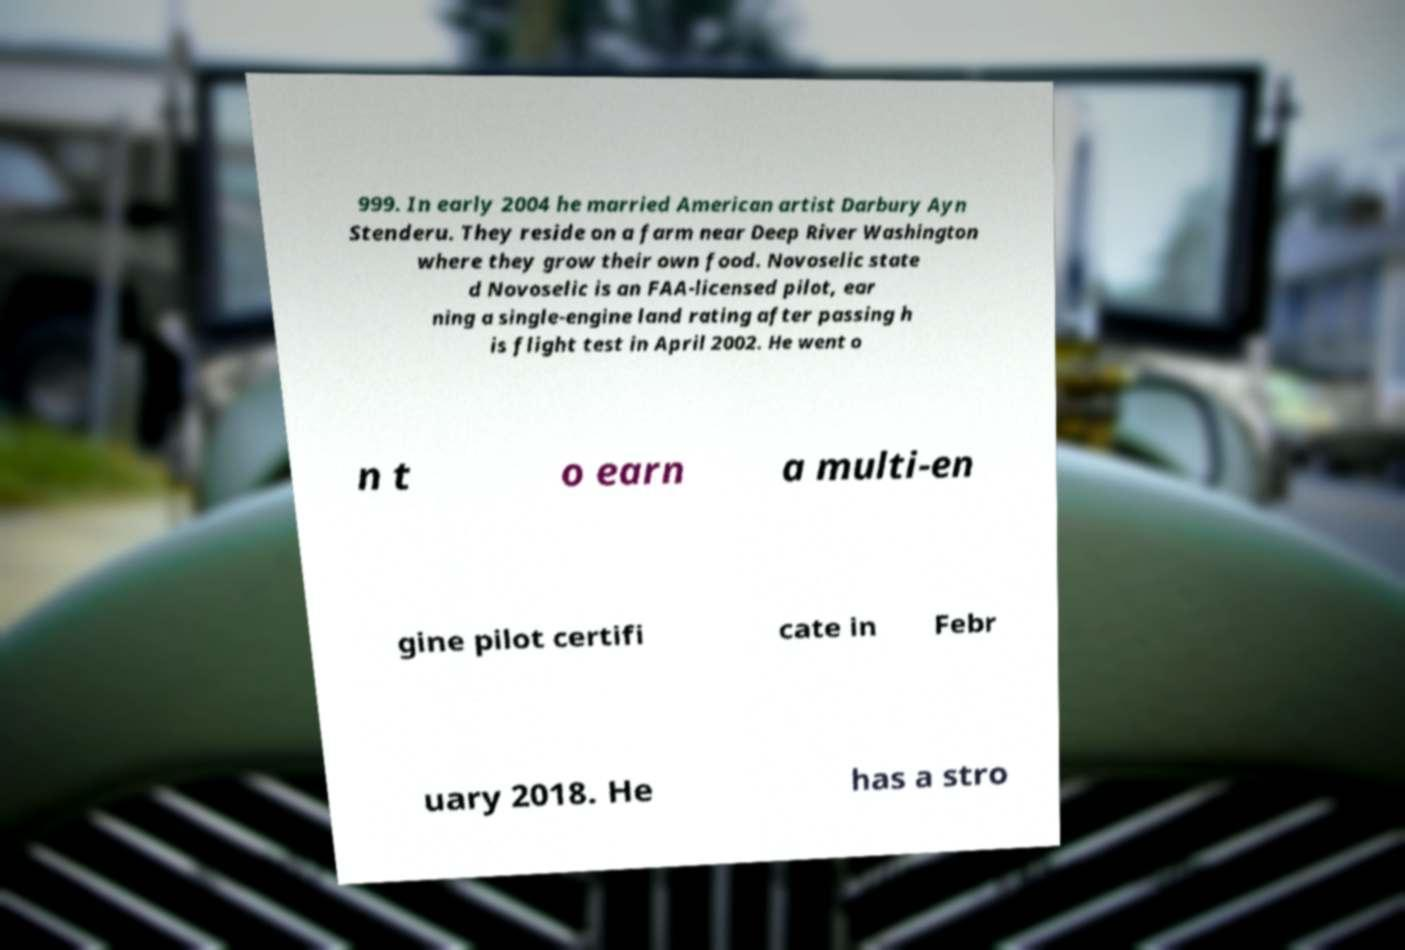Could you extract and type out the text from this image? 999. In early 2004 he married American artist Darbury Ayn Stenderu. They reside on a farm near Deep River Washington where they grow their own food. Novoselic state d Novoselic is an FAA-licensed pilot, ear ning a single-engine land rating after passing h is flight test in April 2002. He went o n t o earn a multi-en gine pilot certifi cate in Febr uary 2018. He has a stro 